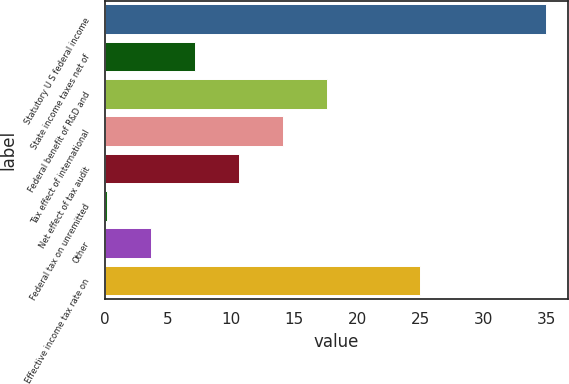Convert chart to OTSL. <chart><loc_0><loc_0><loc_500><loc_500><bar_chart><fcel>Statutory U S federal income<fcel>State income taxes net of<fcel>Federal benefit of R&D and<fcel>Tax effect of international<fcel>Net effect of tax audit<fcel>Federal tax on unremitted<fcel>Other<fcel>Effective income tax rate on<nl><fcel>35<fcel>7.16<fcel>17.6<fcel>14.12<fcel>10.64<fcel>0.2<fcel>3.68<fcel>25<nl></chart> 